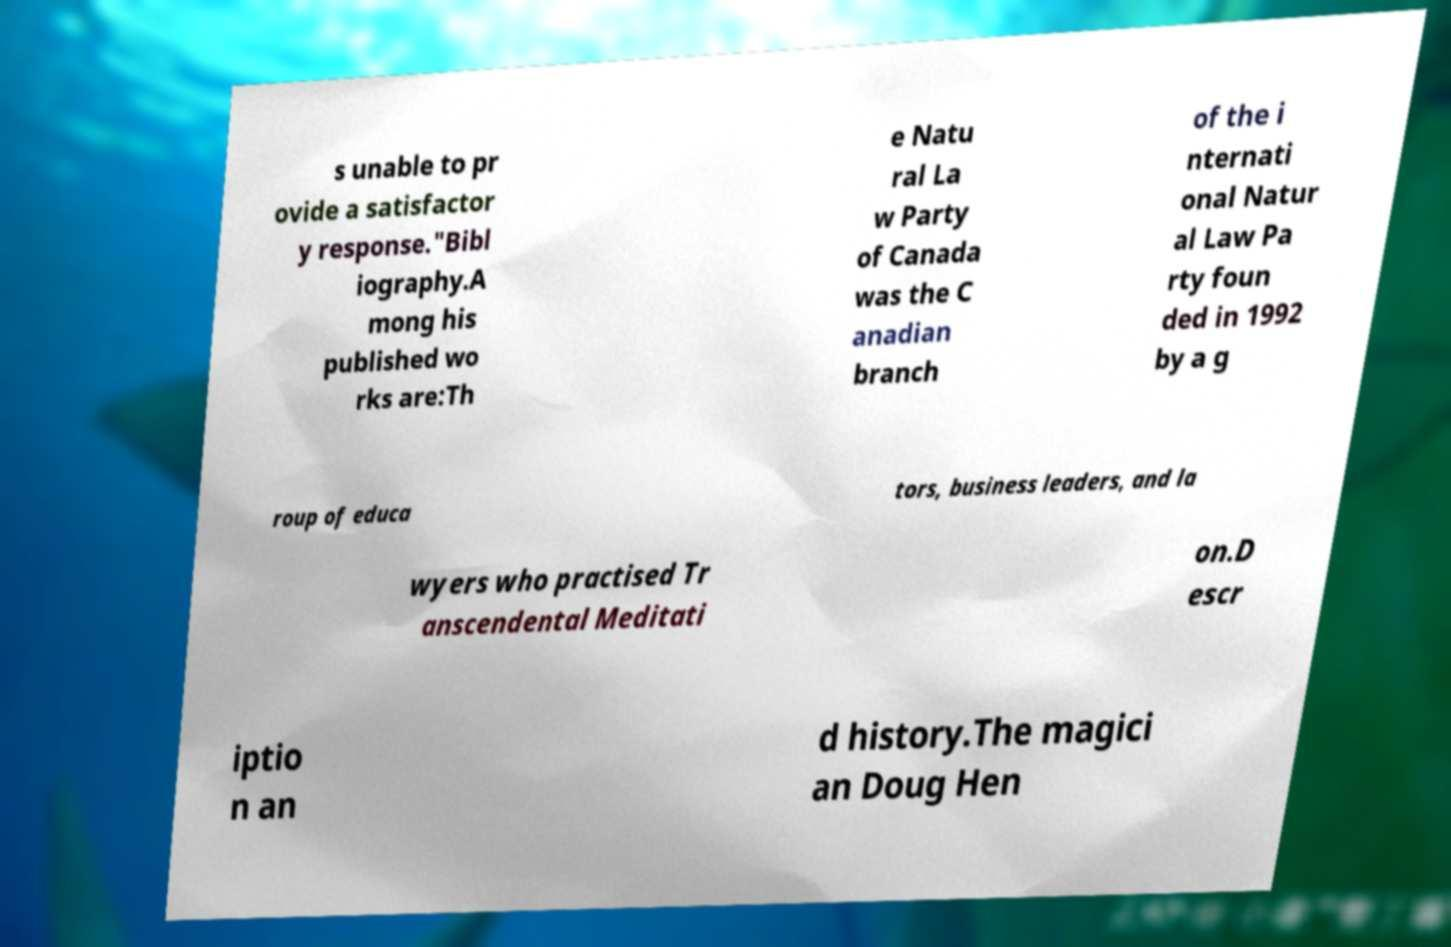Could you assist in decoding the text presented in this image and type it out clearly? s unable to pr ovide a satisfactor y response."Bibl iography.A mong his published wo rks are:Th e Natu ral La w Party of Canada was the C anadian branch of the i nternati onal Natur al Law Pa rty foun ded in 1992 by a g roup of educa tors, business leaders, and la wyers who practised Tr anscendental Meditati on.D escr iptio n an d history.The magici an Doug Hen 